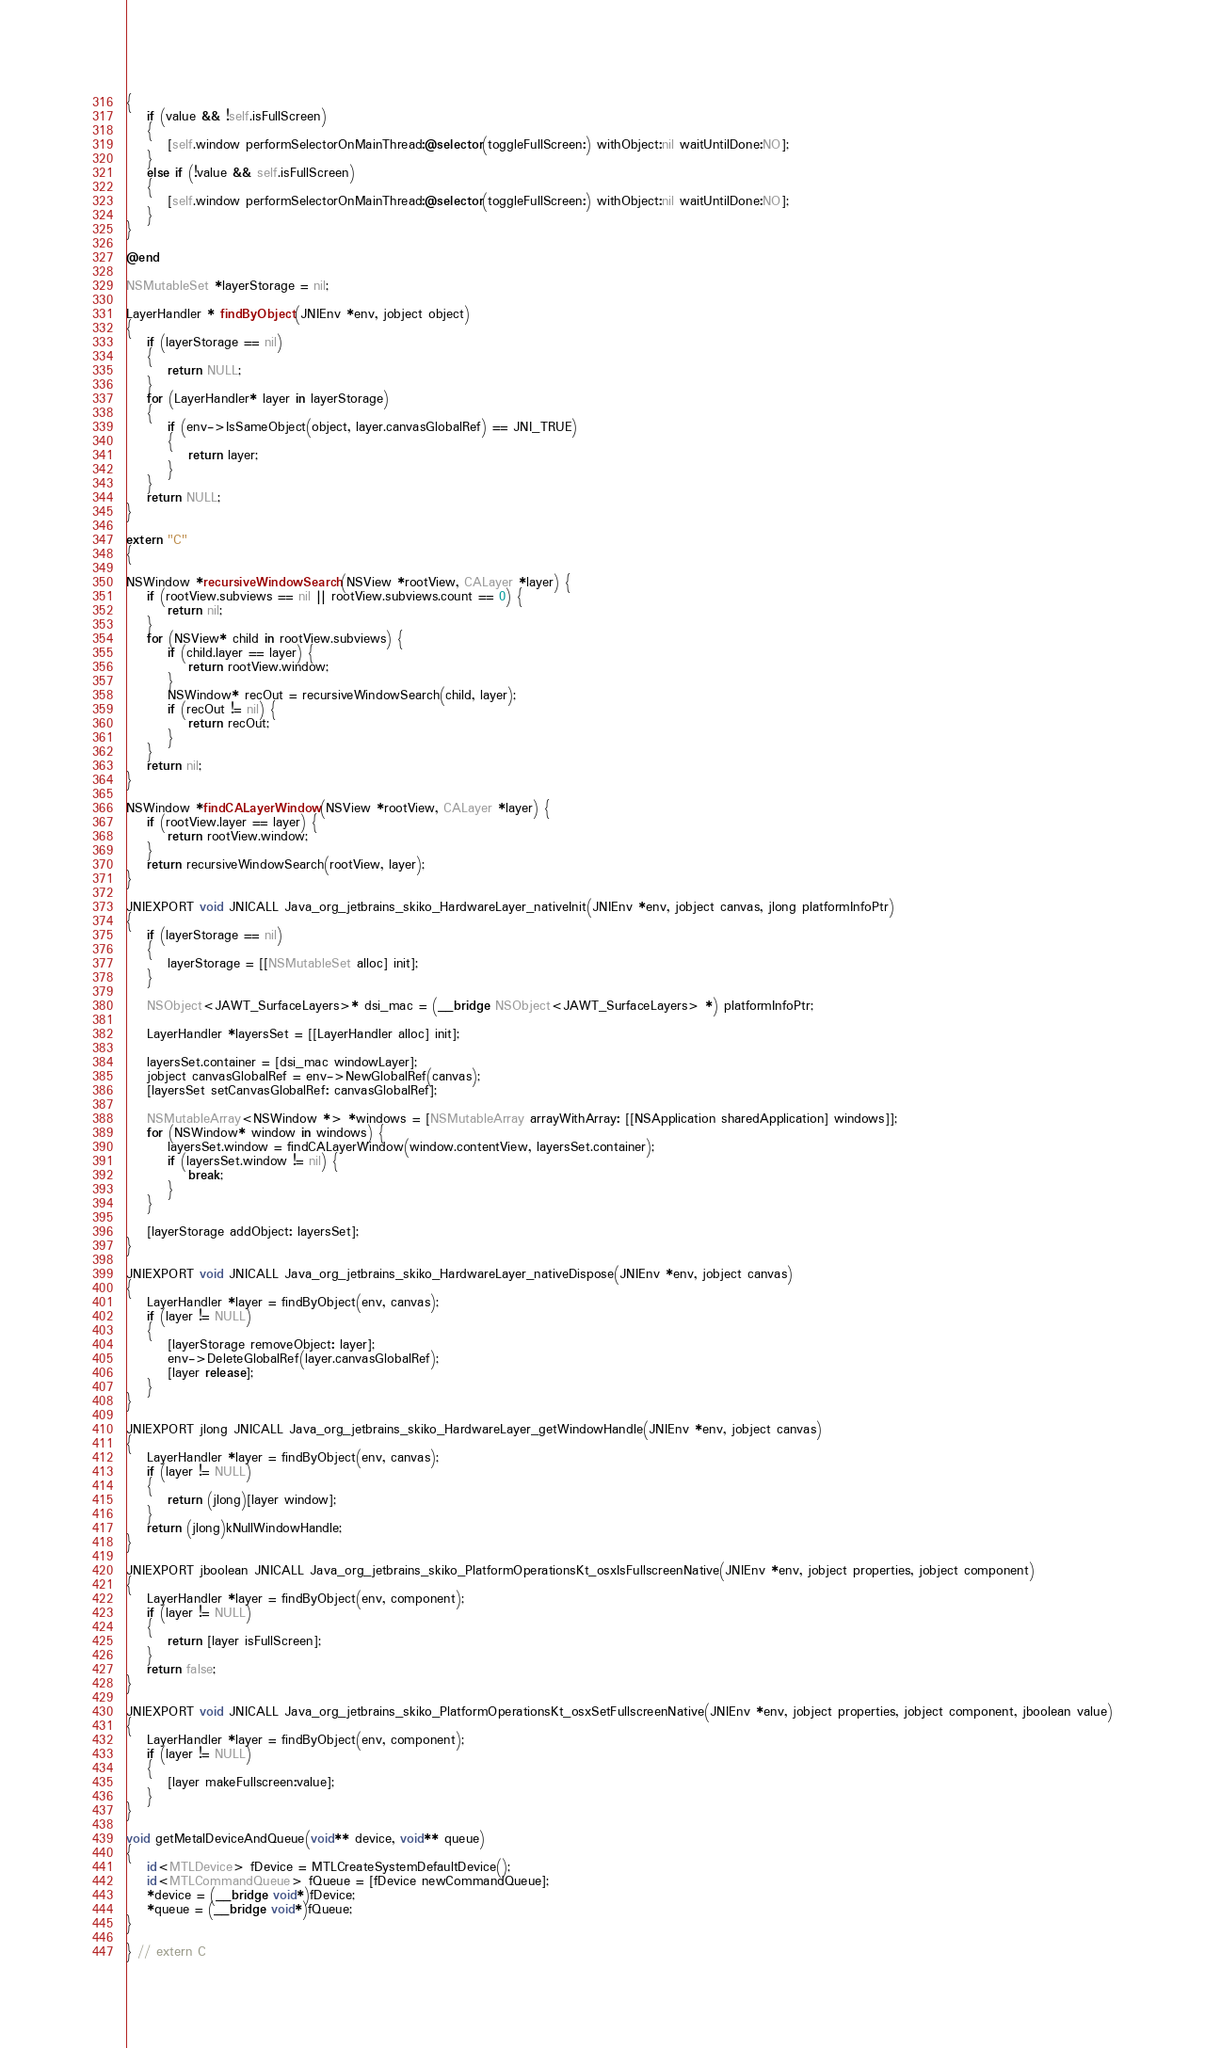<code> <loc_0><loc_0><loc_500><loc_500><_ObjectiveC_>{
    if (value && !self.isFullScreen)
    {
        [self.window performSelectorOnMainThread:@selector(toggleFullScreen:) withObject:nil waitUntilDone:NO];
    }
    else if (!value && self.isFullScreen)
    {
        [self.window performSelectorOnMainThread:@selector(toggleFullScreen:) withObject:nil waitUntilDone:NO];
    }
}

@end

NSMutableSet *layerStorage = nil;

LayerHandler * findByObject(JNIEnv *env, jobject object)
{
    if (layerStorage == nil)
    {
        return NULL;
    }
    for (LayerHandler* layer in layerStorage)
    {
        if (env->IsSameObject(object, layer.canvasGlobalRef) == JNI_TRUE)
        {
            return layer;
        }
    }
    return NULL;
}

extern "C"
{

NSWindow *recursiveWindowSearch(NSView *rootView, CALayer *layer) {
    if (rootView.subviews == nil || rootView.subviews.count == 0) {
        return nil;
    }
    for (NSView* child in rootView.subviews) {
        if (child.layer == layer) {
            return rootView.window;
        }
        NSWindow* recOut = recursiveWindowSearch(child, layer);
        if (recOut != nil) {
            return recOut;
        }
    }
    return nil;
}

NSWindow *findCALayerWindow(NSView *rootView, CALayer *layer) {
    if (rootView.layer == layer) {
        return rootView.window;
    }
    return recursiveWindowSearch(rootView, layer);
}

JNIEXPORT void JNICALL Java_org_jetbrains_skiko_HardwareLayer_nativeInit(JNIEnv *env, jobject canvas, jlong platformInfoPtr)
{
    if (layerStorage == nil)
    {
        layerStorage = [[NSMutableSet alloc] init];
    }

    NSObject<JAWT_SurfaceLayers>* dsi_mac = (__bridge NSObject<JAWT_SurfaceLayers> *) platformInfoPtr;

    LayerHandler *layersSet = [[LayerHandler alloc] init];

    layersSet.container = [dsi_mac windowLayer];
    jobject canvasGlobalRef = env->NewGlobalRef(canvas);
    [layersSet setCanvasGlobalRef: canvasGlobalRef];

    NSMutableArray<NSWindow *> *windows = [NSMutableArray arrayWithArray: [[NSApplication sharedApplication] windows]];
    for (NSWindow* window in windows) {
        layersSet.window = findCALayerWindow(window.contentView, layersSet.container);
        if (layersSet.window != nil) {
            break;
        }
    }

    [layerStorage addObject: layersSet];
}

JNIEXPORT void JNICALL Java_org_jetbrains_skiko_HardwareLayer_nativeDispose(JNIEnv *env, jobject canvas)
{
    LayerHandler *layer = findByObject(env, canvas);
    if (layer != NULL)
    {
        [layerStorage removeObject: layer];
        env->DeleteGlobalRef(layer.canvasGlobalRef);
        [layer release];
    }
}

JNIEXPORT jlong JNICALL Java_org_jetbrains_skiko_HardwareLayer_getWindowHandle(JNIEnv *env, jobject canvas)
{
    LayerHandler *layer = findByObject(env, canvas);
    if (layer != NULL)
    {
        return (jlong)[layer window];
    }
    return (jlong)kNullWindowHandle;
}

JNIEXPORT jboolean JNICALL Java_org_jetbrains_skiko_PlatformOperationsKt_osxIsFullscreenNative(JNIEnv *env, jobject properties, jobject component)
{
    LayerHandler *layer = findByObject(env, component);
    if (layer != NULL)
    {
        return [layer isFullScreen];
    }
    return false;
}

JNIEXPORT void JNICALL Java_org_jetbrains_skiko_PlatformOperationsKt_osxSetFullscreenNative(JNIEnv *env, jobject properties, jobject component, jboolean value)
{
    LayerHandler *layer = findByObject(env, component);
    if (layer != NULL)
    {
        [layer makeFullscreen:value];
    }
}

void getMetalDeviceAndQueue(void** device, void** queue)
{
    id<MTLDevice> fDevice = MTLCreateSystemDefaultDevice();
    id<MTLCommandQueue> fQueue = [fDevice newCommandQueue];
    *device = (__bridge void*)fDevice;
    *queue = (__bridge void*)fQueue;
}

} // extern C</code> 